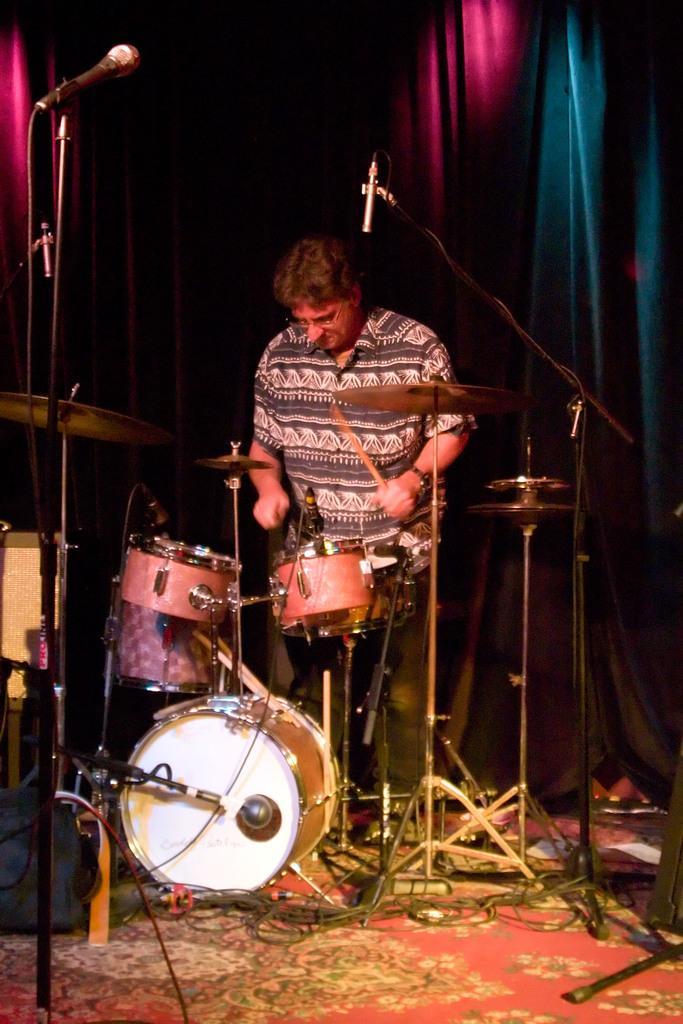Could you give a brief overview of what you see in this image? In this image we can see a person standing. And we can see the microphones, drums and some other musical instruments. In the background, we can see the curtains. 